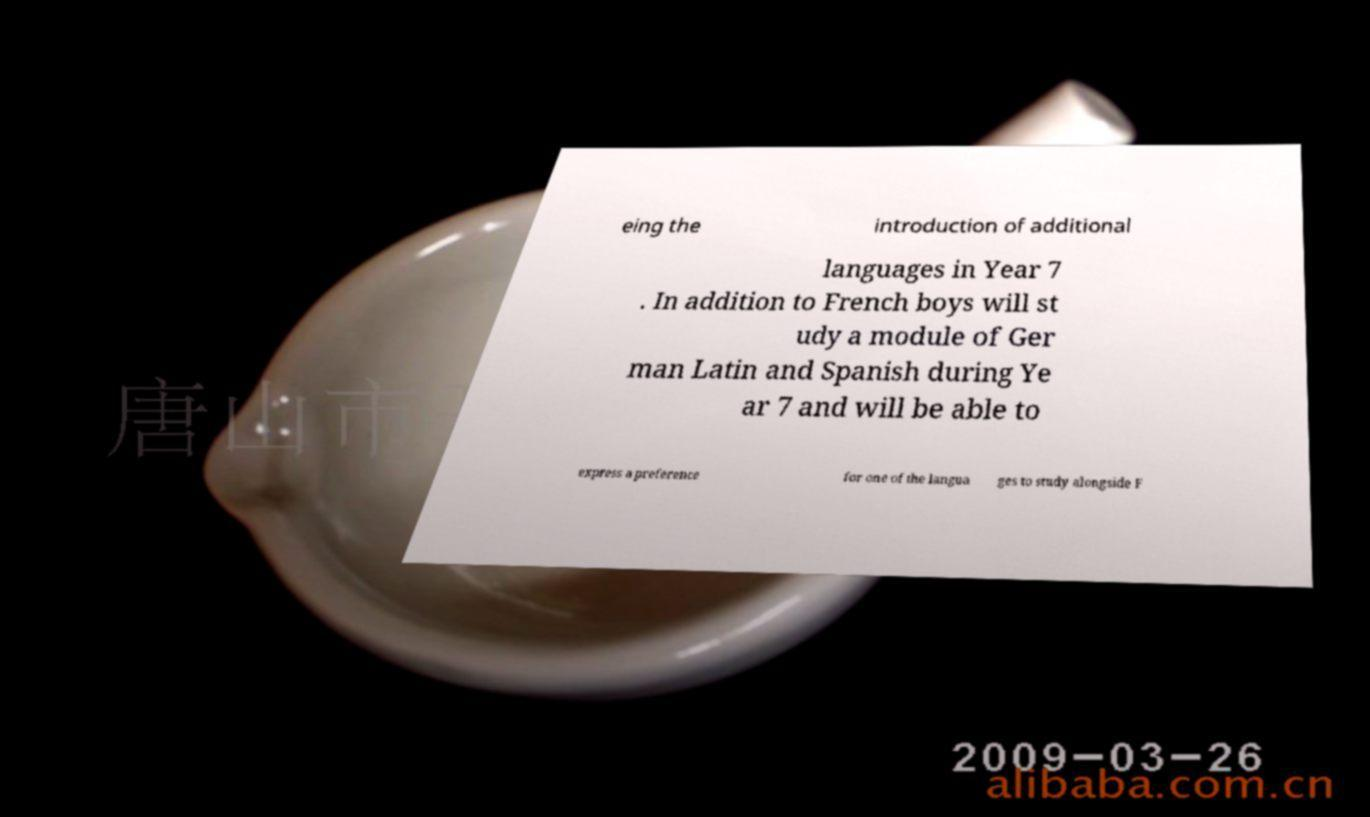Could you assist in decoding the text presented in this image and type it out clearly? eing the introduction of additional languages in Year 7 . In addition to French boys will st udy a module of Ger man Latin and Spanish during Ye ar 7 and will be able to express a preference for one of the langua ges to study alongside F 